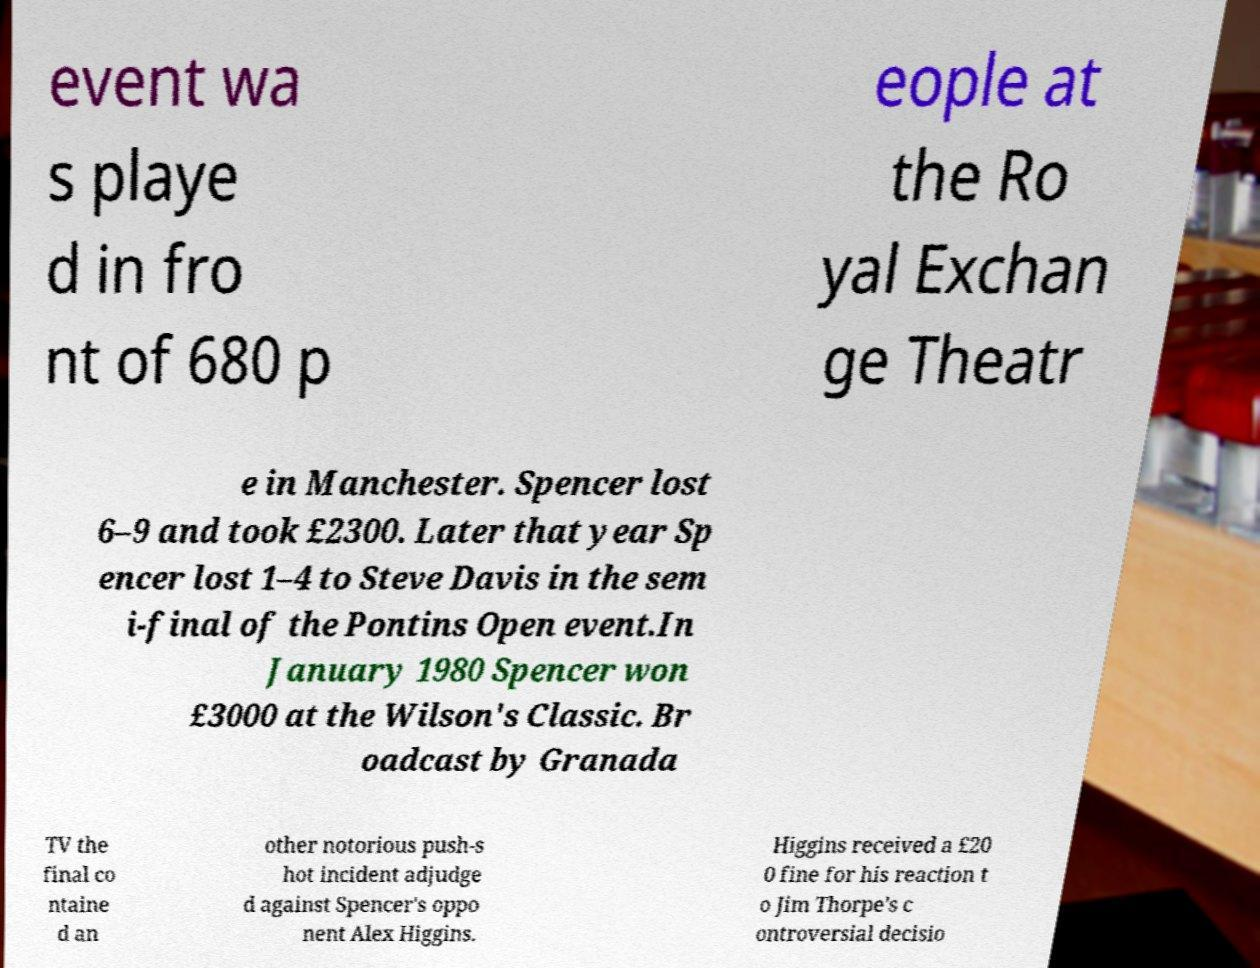Please identify and transcribe the text found in this image. event wa s playe d in fro nt of 680 p eople at the Ro yal Exchan ge Theatr e in Manchester. Spencer lost 6–9 and took £2300. Later that year Sp encer lost 1–4 to Steve Davis in the sem i-final of the Pontins Open event.In January 1980 Spencer won £3000 at the Wilson's Classic. Br oadcast by Granada TV the final co ntaine d an other notorious push-s hot incident adjudge d against Spencer's oppo nent Alex Higgins. Higgins received a £20 0 fine for his reaction t o Jim Thorpe's c ontroversial decisio 